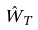Convert formula to latex. <formula><loc_0><loc_0><loc_500><loc_500>\hat { W } _ { T }</formula> 